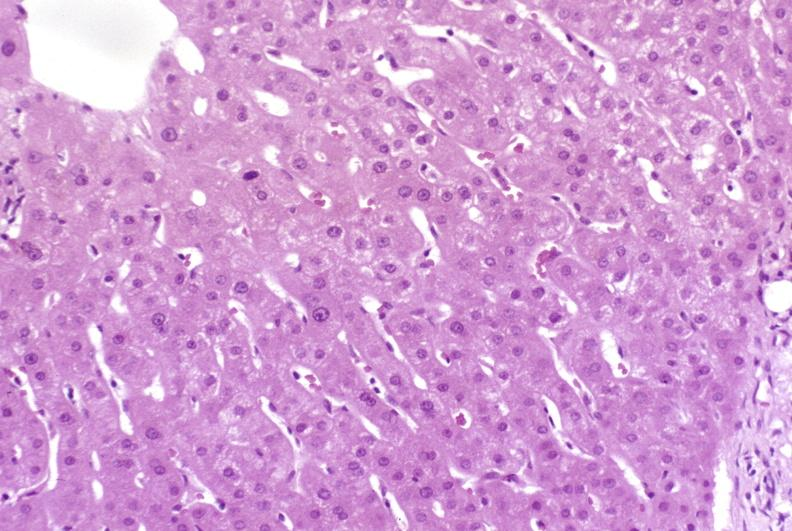does this image show resolving acute rejection?
Answer the question using a single word or phrase. Yes 